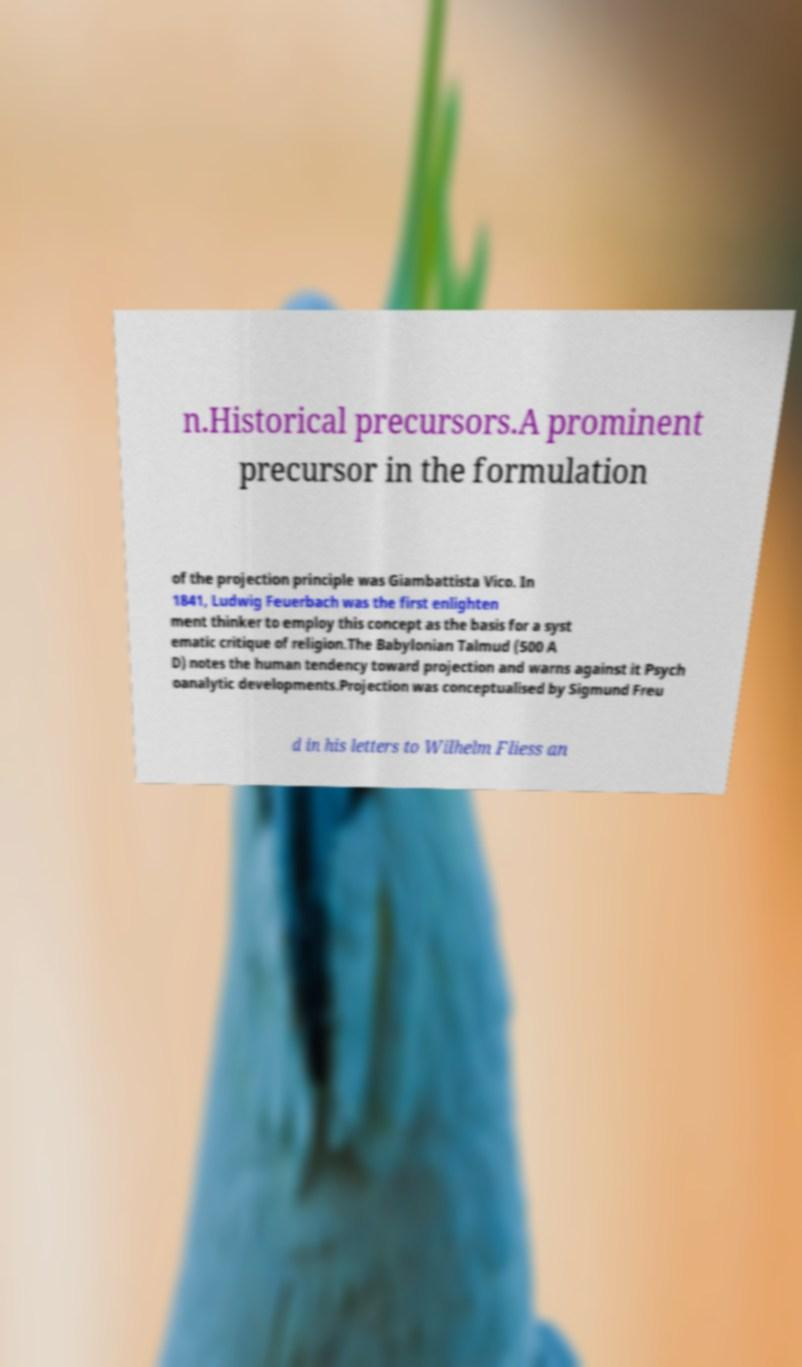Please identify and transcribe the text found in this image. n.Historical precursors.A prominent precursor in the formulation of the projection principle was Giambattista Vico. In 1841, Ludwig Feuerbach was the first enlighten ment thinker to employ this concept as the basis for a syst ematic critique of religion.The Babylonian Talmud (500 A D) notes the human tendency toward projection and warns against it Psych oanalytic developments.Projection was conceptualised by Sigmund Freu d in his letters to Wilhelm Fliess an 